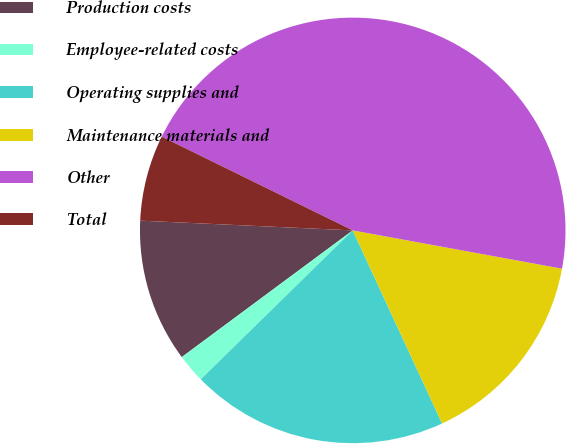Convert chart to OTSL. <chart><loc_0><loc_0><loc_500><loc_500><pie_chart><fcel>Production costs<fcel>Employee-related costs<fcel>Operating supplies and<fcel>Maintenance materials and<fcel>Other<fcel>Total<nl><fcel>10.88%<fcel>2.19%<fcel>19.56%<fcel>15.22%<fcel>45.62%<fcel>6.53%<nl></chart> 